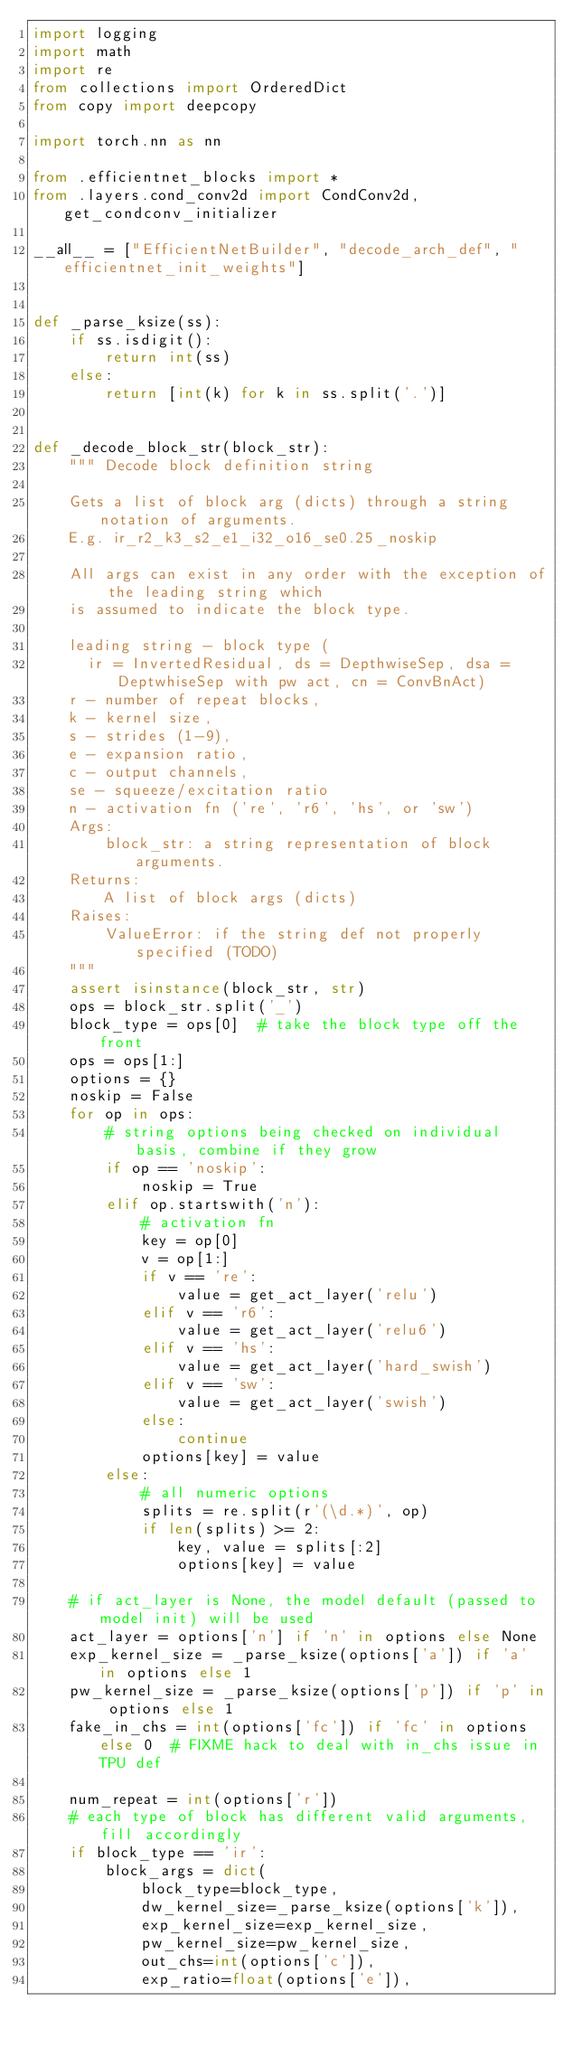<code> <loc_0><loc_0><loc_500><loc_500><_Python_>import logging
import math
import re
from collections import OrderedDict
from copy import deepcopy

import torch.nn as nn

from .efficientnet_blocks import *
from .layers.cond_conv2d import CondConv2d, get_condconv_initializer

__all__ = ["EfficientNetBuilder", "decode_arch_def", "efficientnet_init_weights"]


def _parse_ksize(ss):
    if ss.isdigit():
        return int(ss)
    else:
        return [int(k) for k in ss.split('.')]


def _decode_block_str(block_str):
    """ Decode block definition string

    Gets a list of block arg (dicts) through a string notation of arguments.
    E.g. ir_r2_k3_s2_e1_i32_o16_se0.25_noskip

    All args can exist in any order with the exception of the leading string which
    is assumed to indicate the block type.

    leading string - block type (
      ir = InvertedResidual, ds = DepthwiseSep, dsa = DeptwhiseSep with pw act, cn = ConvBnAct)
    r - number of repeat blocks,
    k - kernel size,
    s - strides (1-9),
    e - expansion ratio,
    c - output channels,
    se - squeeze/excitation ratio
    n - activation fn ('re', 'r6', 'hs', or 'sw')
    Args:
        block_str: a string representation of block arguments.
    Returns:
        A list of block args (dicts)
    Raises:
        ValueError: if the string def not properly specified (TODO)
    """
    assert isinstance(block_str, str)
    ops = block_str.split('_')
    block_type = ops[0]  # take the block type off the front
    ops = ops[1:]
    options = {}
    noskip = False
    for op in ops:
        # string options being checked on individual basis, combine if they grow
        if op == 'noskip':
            noskip = True
        elif op.startswith('n'):
            # activation fn
            key = op[0]
            v = op[1:]
            if v == 're':
                value = get_act_layer('relu')
            elif v == 'r6':
                value = get_act_layer('relu6')
            elif v == 'hs':
                value = get_act_layer('hard_swish')
            elif v == 'sw':
                value = get_act_layer('swish')
            else:
                continue
            options[key] = value
        else:
            # all numeric options
            splits = re.split(r'(\d.*)', op)
            if len(splits) >= 2:
                key, value = splits[:2]
                options[key] = value

    # if act_layer is None, the model default (passed to model init) will be used
    act_layer = options['n'] if 'n' in options else None
    exp_kernel_size = _parse_ksize(options['a']) if 'a' in options else 1
    pw_kernel_size = _parse_ksize(options['p']) if 'p' in options else 1
    fake_in_chs = int(options['fc']) if 'fc' in options else 0  # FIXME hack to deal with in_chs issue in TPU def

    num_repeat = int(options['r'])
    # each type of block has different valid arguments, fill accordingly
    if block_type == 'ir':
        block_args = dict(
            block_type=block_type,
            dw_kernel_size=_parse_ksize(options['k']),
            exp_kernel_size=exp_kernel_size,
            pw_kernel_size=pw_kernel_size,
            out_chs=int(options['c']),
            exp_ratio=float(options['e']),</code> 